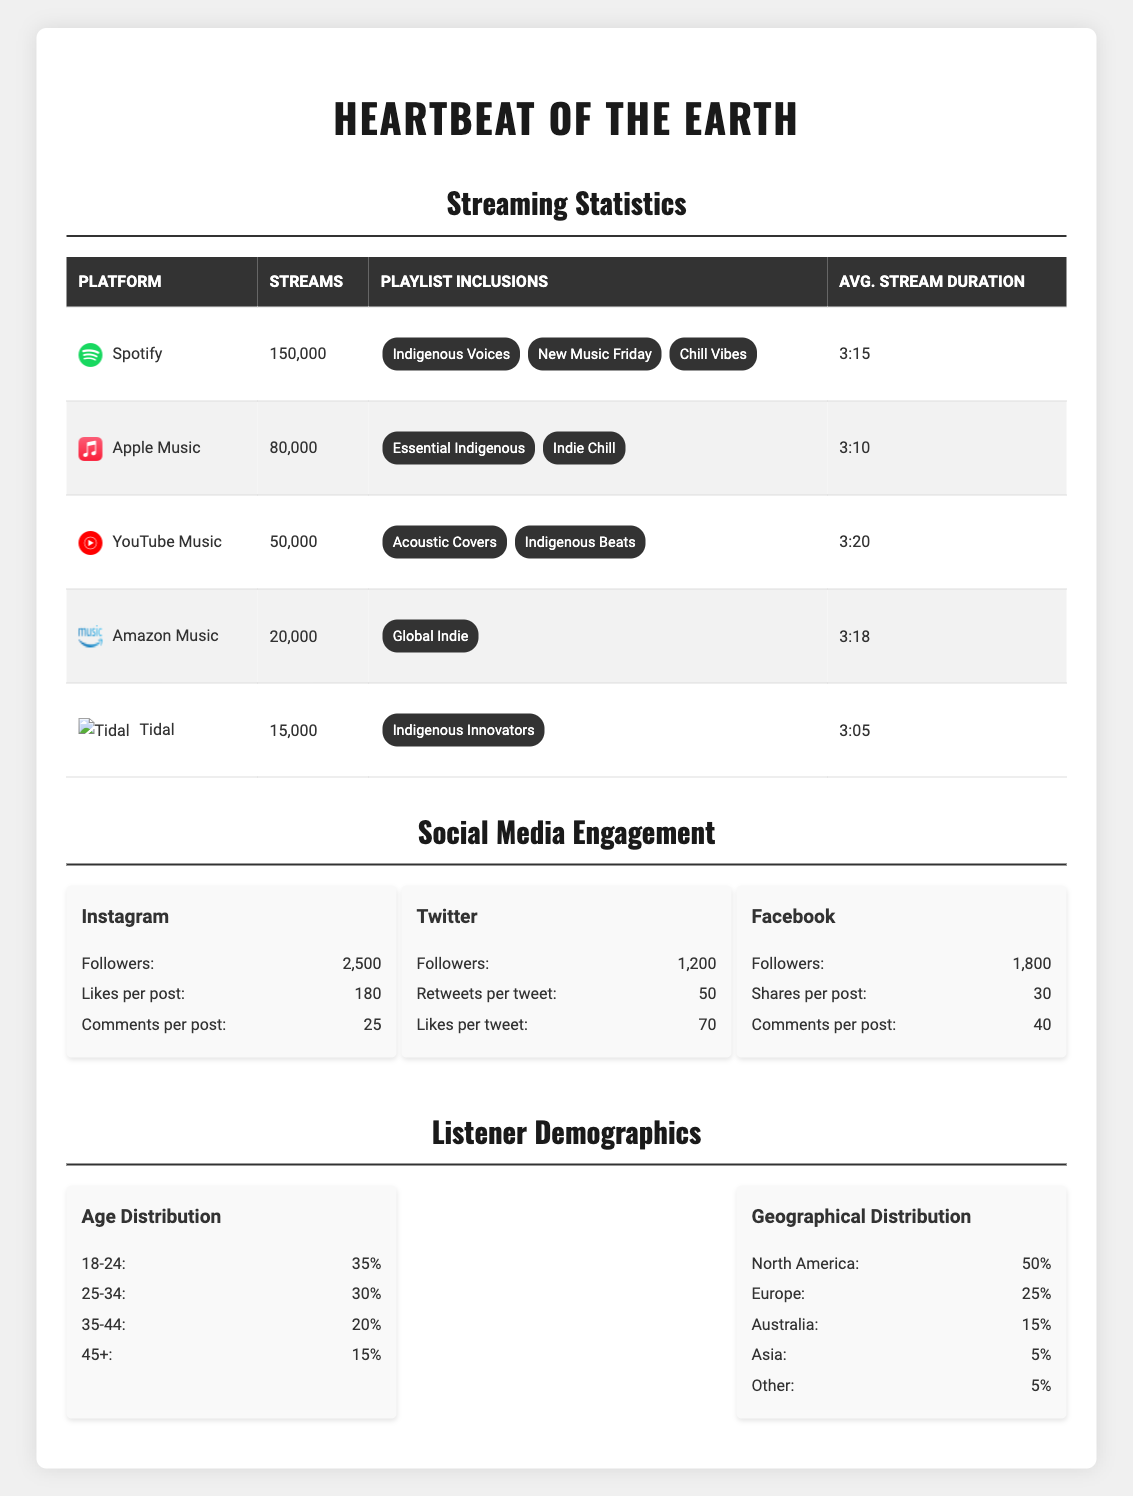What is the total number of streams across all platforms? The total number of streams can be found in the table under the total streams category, which states it as 300,000.
Answer: 300,000 Which platform has the highest number of streams? By comparing the streams for each platform, Spotify has the highest with 150,000 streams.
Answer: Spotify How many playlists includes the single on Spotify? The table lists three playlists for Spotify: Indigenous Voices, New Music Friday, and Chill Vibes.
Answer: 3 What is the average stream duration on YouTube Music? The average stream duration for YouTube Music is listed as 3:20.
Answer: 3:20 What percentage of total streams comes from Apple Music? Apple Music contributed 80,000 streams. To find the percentage, calculate (80,000 / 300,000) * 100 = 26.67%.
Answer: 26.67% What is the smallest number of streams among all platforms? The smallest number of streams is 15,000, which belongs to Tidal according to the table.
Answer: 15,000 How many playlists feature the single on Amazon Music? There is one playlist that includes the single, which is Global Indie according to the table.
Answer: 1 Is the average stream duration longer on Spotify than on Tidal? The average stream duration for Spotify is 3:15 and for Tidal is 3:05; since 3:15 is longer than 3:05, the answer is yes.
Answer: Yes What age group has the highest percentage of listeners? The age group 18-24 has the highest percentage of listeners at 35%.
Answer: 18-24 How many more streams does Spotify have compared to Apple Music? The difference in streams can be calculated by subtracting Apple Music's streams (80,000) from Spotify's streams (150,000), which gives a result of 70,000.
Answer: 70,000 What is the total percentage of listeners aged 35 and above? Adding the percentages of listeners aged 35-44 (20%) and 45+ (15%) gives a total of 35%.
Answer: 35% How many countries account for the geographical distribution of more than 50% of listeners? North America (50%) alone contributes to most listeners, and combined with Europe (25%), the two regions together account for 75%. Thus, there are 2 regions.
Answer: 2 